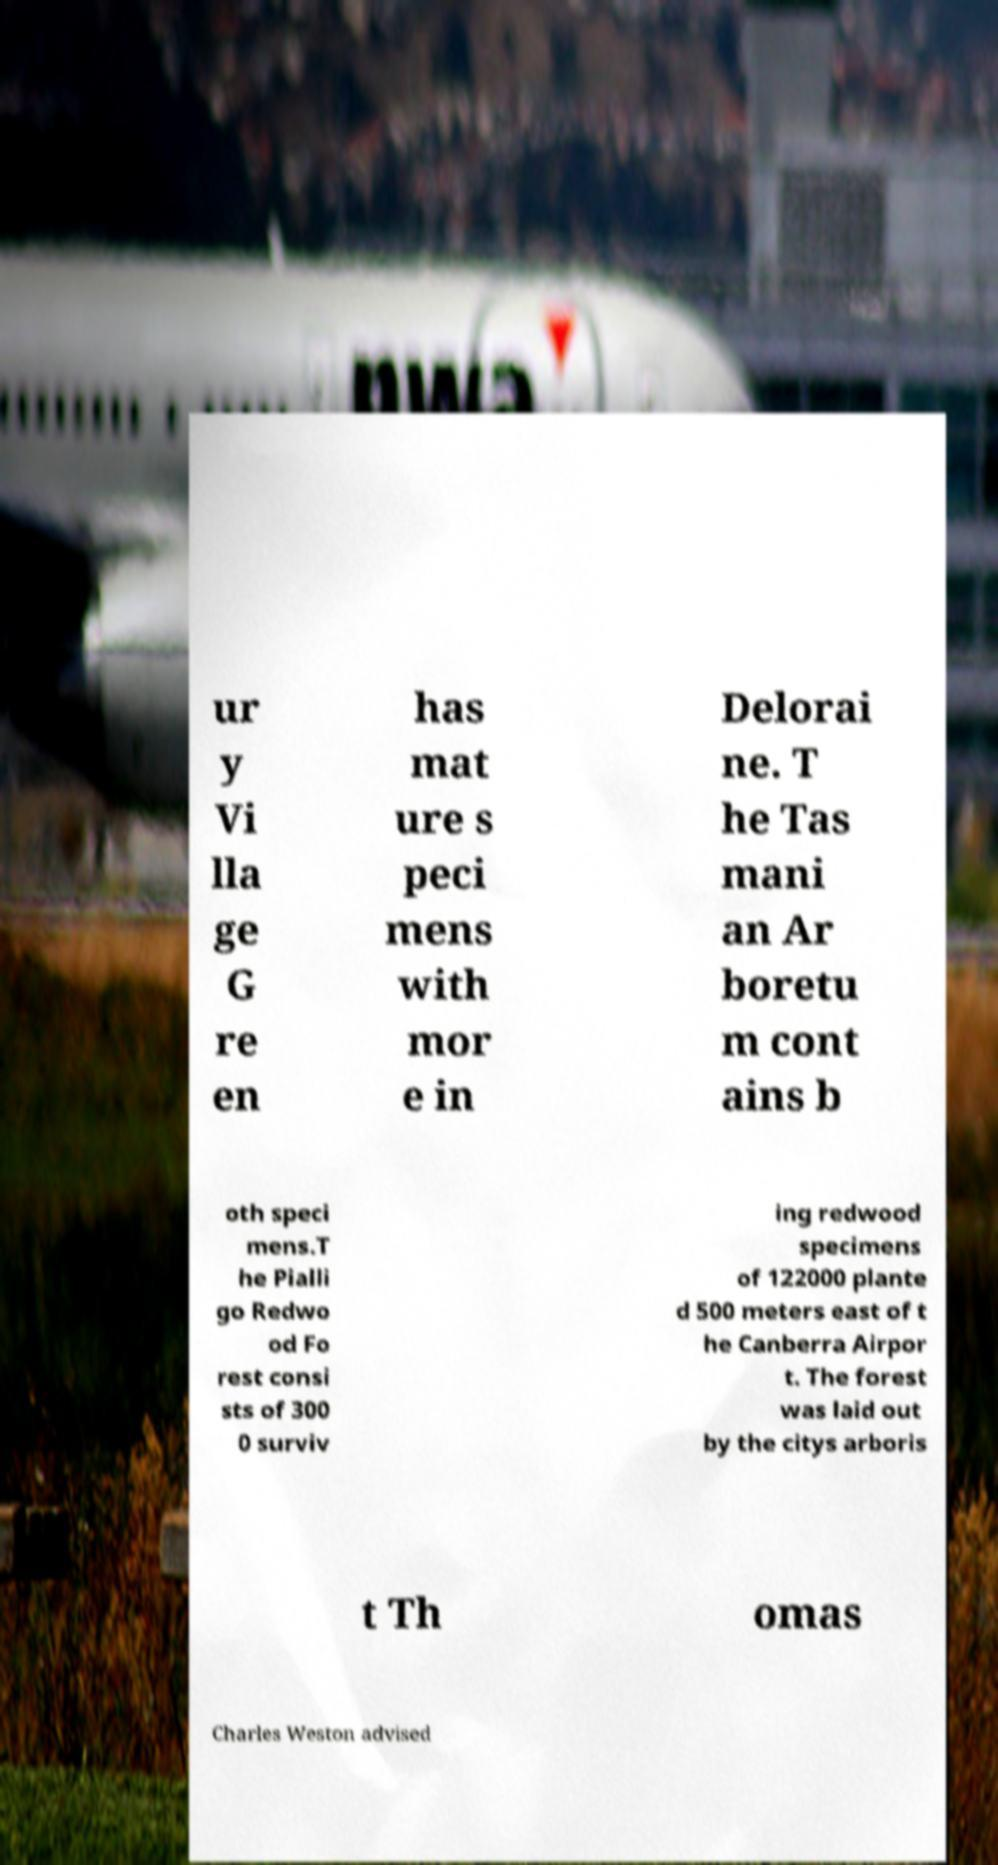What messages or text are displayed in this image? I need them in a readable, typed format. ur y Vi lla ge G re en has mat ure s peci mens with mor e in Delorai ne. T he Tas mani an Ar boretu m cont ains b oth speci mens.T he Pialli go Redwo od Fo rest consi sts of 300 0 surviv ing redwood specimens of 122000 plante d 500 meters east of t he Canberra Airpor t. The forest was laid out by the citys arboris t Th omas Charles Weston advised 